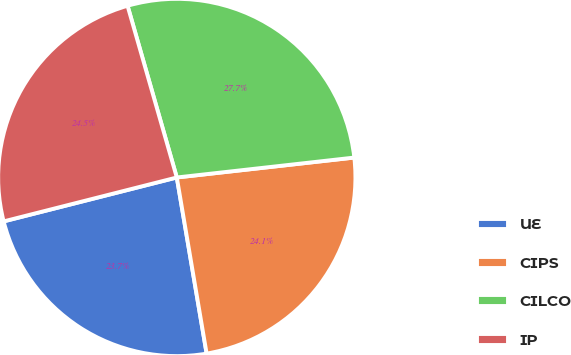Convert chart to OTSL. <chart><loc_0><loc_0><loc_500><loc_500><pie_chart><fcel>UE<fcel>CIPS<fcel>CILCO<fcel>IP<nl><fcel>23.72%<fcel>24.11%<fcel>27.67%<fcel>24.51%<nl></chart> 